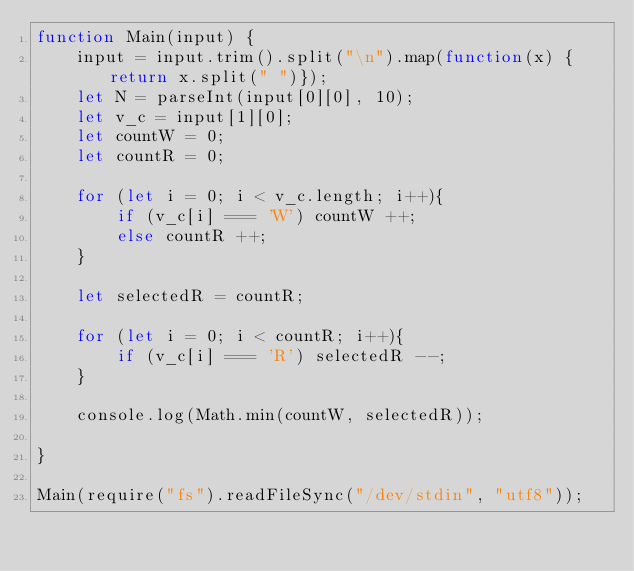<code> <loc_0><loc_0><loc_500><loc_500><_JavaScript_>function Main(input) {
	input = input.trim().split("\n").map(function(x) { return x.split(" ")});
    let N = parseInt(input[0][0], 10);
    let v_c = input[1][0];
    let countW = 0;
    let countR = 0;
    
    for (let i = 0; i < v_c.length; i++){
        if (v_c[i] === 'W') countW ++;
        else countR ++;
    }

    let selectedR = countR;

    for (let i = 0; i < countR; i++){
        if (v_c[i] === 'R') selectedR --;
    }
    
	console.log(Math.min(countW, selectedR));
	
}

Main(require("fs").readFileSync("/dev/stdin", "utf8"));
</code> 